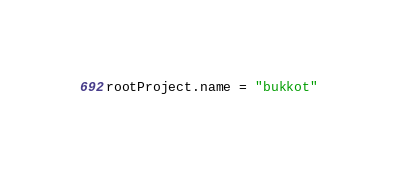<code> <loc_0><loc_0><loc_500><loc_500><_Kotlin_>rootProject.name = "bukkot"</code> 